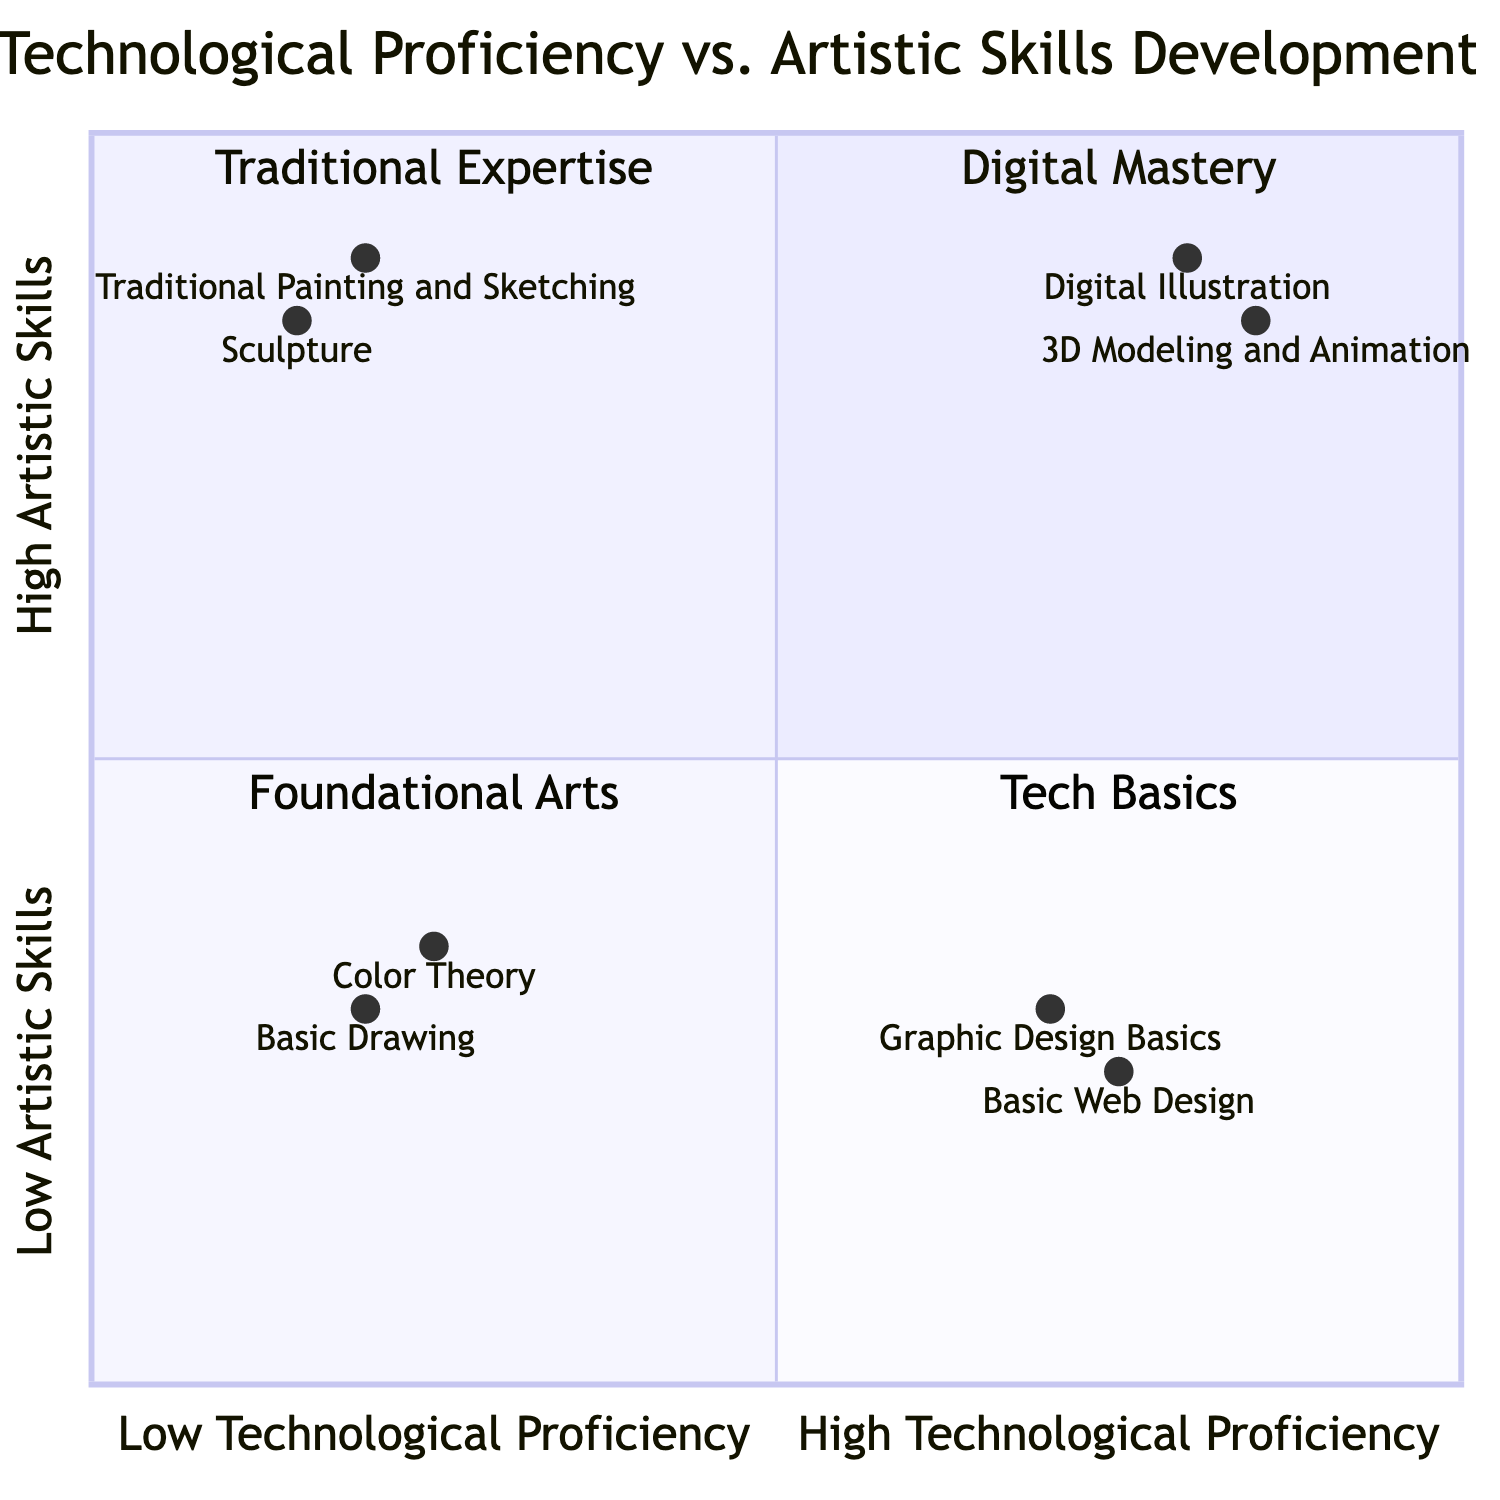What elements are found in the High Technological Proficiency - High Artistic Skills quadrant? The diagram identifies "Digital Illustration" and "3D Modeling and Animation" as elements in this quadrant, indicating the combination of high technological proficiency and artistic skill.
Answer: Digital Illustration, 3D Modeling and Animation How many elements are located in the Low Technological Proficiency - Low Artistic Skills quadrant? By inspecting the diagram, there are two elements: "Basic Drawing" and "Color Theory," confirming that there are a total of two elements in this quadrant.
Answer: 2 Which element ranks highest in Technological Proficiency? The highest ranking in Technological Proficiency is held by "3D Modeling and Animation" with a value of 0.85, making it the highest in the technological aspect among all elements portrayed in the chart.
Answer: 3D Modeling and Animation What is the combined total of artistic skill values for the elements in the Tech Basics quadrant? Reviewing the chart, "Graphic Design Basics" is valued at 0.3 and "Basic Web Design" at 0.25, so summing these gives 0.3 + 0.25 = 0.55 as the combined total for artistic skill values within this quadrant.
Answer: 0.55 In which quadrant can "Traditional Painting and Sketching" be found? Analyzing the quadrant chart places "Traditional Painting and Sketching" in the Low Technological Proficiency - High Artistic Skills quadrant, wherein it demonstrates high artistic capability alongside lower tech use.
Answer: Traditional Expertise 